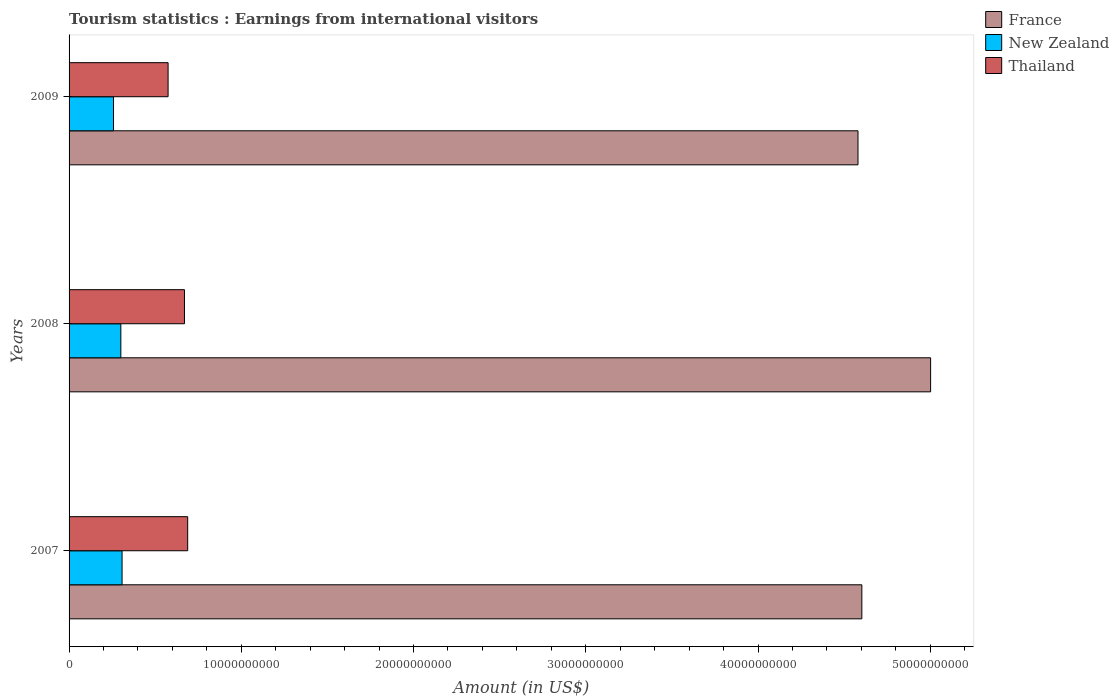How many different coloured bars are there?
Keep it short and to the point. 3. How many groups of bars are there?
Give a very brief answer. 3. Are the number of bars per tick equal to the number of legend labels?
Your response must be concise. Yes. In how many cases, is the number of bars for a given year not equal to the number of legend labels?
Provide a succinct answer. 0. What is the earnings from international visitors in Thailand in 2007?
Offer a terse response. 6.89e+09. Across all years, what is the maximum earnings from international visitors in New Zealand?
Offer a terse response. 3.08e+09. Across all years, what is the minimum earnings from international visitors in New Zealand?
Ensure brevity in your answer.  2.58e+09. In which year was the earnings from international visitors in France maximum?
Provide a succinct answer. 2008. In which year was the earnings from international visitors in France minimum?
Provide a short and direct response. 2009. What is the total earnings from international visitors in New Zealand in the graph?
Your answer should be very brief. 8.66e+09. What is the difference between the earnings from international visitors in Thailand in 2008 and that in 2009?
Make the answer very short. 9.51e+08. What is the difference between the earnings from international visitors in France in 2008 and the earnings from international visitors in Thailand in 2007?
Ensure brevity in your answer.  4.31e+1. What is the average earnings from international visitors in France per year?
Give a very brief answer. 4.73e+1. In the year 2009, what is the difference between the earnings from international visitors in Thailand and earnings from international visitors in France?
Provide a succinct answer. -4.01e+1. In how many years, is the earnings from international visitors in Thailand greater than 14000000000 US$?
Your answer should be very brief. 0. What is the ratio of the earnings from international visitors in France in 2008 to that in 2009?
Your answer should be compact. 1.09. Is the earnings from international visitors in France in 2008 less than that in 2009?
Your answer should be very brief. No. Is the difference between the earnings from international visitors in Thailand in 2007 and 2008 greater than the difference between the earnings from international visitors in France in 2007 and 2008?
Your answer should be very brief. Yes. What is the difference between the highest and the second highest earnings from international visitors in New Zealand?
Offer a very short reply. 7.10e+07. What is the difference between the highest and the lowest earnings from international visitors in New Zealand?
Your answer should be very brief. 4.97e+08. What does the 2nd bar from the top in 2008 represents?
Your response must be concise. New Zealand. What does the 2nd bar from the bottom in 2009 represents?
Your answer should be compact. New Zealand. Is it the case that in every year, the sum of the earnings from international visitors in Thailand and earnings from international visitors in New Zealand is greater than the earnings from international visitors in France?
Provide a succinct answer. No. How many bars are there?
Provide a short and direct response. 9. Are all the bars in the graph horizontal?
Offer a very short reply. Yes. How many years are there in the graph?
Your answer should be compact. 3. What is the difference between two consecutive major ticks on the X-axis?
Your response must be concise. 1.00e+1. Are the values on the major ticks of X-axis written in scientific E-notation?
Provide a short and direct response. No. How many legend labels are there?
Your answer should be very brief. 3. How are the legend labels stacked?
Keep it short and to the point. Vertical. What is the title of the graph?
Provide a short and direct response. Tourism statistics : Earnings from international visitors. What is the Amount (in US$) in France in 2007?
Your response must be concise. 4.60e+1. What is the Amount (in US$) in New Zealand in 2007?
Give a very brief answer. 3.08e+09. What is the Amount (in US$) in Thailand in 2007?
Keep it short and to the point. 6.89e+09. What is the Amount (in US$) in France in 2008?
Provide a short and direct response. 5.00e+1. What is the Amount (in US$) of New Zealand in 2008?
Offer a terse response. 3.01e+09. What is the Amount (in US$) of Thailand in 2008?
Your response must be concise. 6.70e+09. What is the Amount (in US$) in France in 2009?
Provide a succinct answer. 4.58e+1. What is the Amount (in US$) of New Zealand in 2009?
Provide a succinct answer. 2.58e+09. What is the Amount (in US$) in Thailand in 2009?
Ensure brevity in your answer.  5.75e+09. Across all years, what is the maximum Amount (in US$) in France?
Your answer should be very brief. 5.00e+1. Across all years, what is the maximum Amount (in US$) of New Zealand?
Offer a very short reply. 3.08e+09. Across all years, what is the maximum Amount (in US$) in Thailand?
Keep it short and to the point. 6.89e+09. Across all years, what is the minimum Amount (in US$) in France?
Make the answer very short. 4.58e+1. Across all years, what is the minimum Amount (in US$) in New Zealand?
Ensure brevity in your answer.  2.58e+09. Across all years, what is the minimum Amount (in US$) of Thailand?
Make the answer very short. 5.75e+09. What is the total Amount (in US$) in France in the graph?
Your answer should be compact. 1.42e+11. What is the total Amount (in US$) of New Zealand in the graph?
Your response must be concise. 8.66e+09. What is the total Amount (in US$) of Thailand in the graph?
Ensure brevity in your answer.  1.93e+1. What is the difference between the Amount (in US$) in France in 2007 and that in 2008?
Make the answer very short. -3.99e+09. What is the difference between the Amount (in US$) of New Zealand in 2007 and that in 2008?
Provide a short and direct response. 7.10e+07. What is the difference between the Amount (in US$) of Thailand in 2007 and that in 2008?
Keep it short and to the point. 1.87e+08. What is the difference between the Amount (in US$) of France in 2007 and that in 2009?
Your answer should be very brief. 2.23e+08. What is the difference between the Amount (in US$) in New Zealand in 2007 and that in 2009?
Ensure brevity in your answer.  4.97e+08. What is the difference between the Amount (in US$) of Thailand in 2007 and that in 2009?
Ensure brevity in your answer.  1.14e+09. What is the difference between the Amount (in US$) in France in 2008 and that in 2009?
Make the answer very short. 4.22e+09. What is the difference between the Amount (in US$) of New Zealand in 2008 and that in 2009?
Your answer should be compact. 4.26e+08. What is the difference between the Amount (in US$) of Thailand in 2008 and that in 2009?
Your answer should be compact. 9.51e+08. What is the difference between the Amount (in US$) in France in 2007 and the Amount (in US$) in New Zealand in 2008?
Provide a short and direct response. 4.30e+1. What is the difference between the Amount (in US$) in France in 2007 and the Amount (in US$) in Thailand in 2008?
Give a very brief answer. 3.93e+1. What is the difference between the Amount (in US$) in New Zealand in 2007 and the Amount (in US$) in Thailand in 2008?
Offer a terse response. -3.62e+09. What is the difference between the Amount (in US$) of France in 2007 and the Amount (in US$) of New Zealand in 2009?
Your answer should be very brief. 4.34e+1. What is the difference between the Amount (in US$) in France in 2007 and the Amount (in US$) in Thailand in 2009?
Offer a terse response. 4.03e+1. What is the difference between the Amount (in US$) of New Zealand in 2007 and the Amount (in US$) of Thailand in 2009?
Provide a short and direct response. -2.67e+09. What is the difference between the Amount (in US$) of France in 2008 and the Amount (in US$) of New Zealand in 2009?
Provide a short and direct response. 4.74e+1. What is the difference between the Amount (in US$) of France in 2008 and the Amount (in US$) of Thailand in 2009?
Your answer should be compact. 4.43e+1. What is the difference between the Amount (in US$) in New Zealand in 2008 and the Amount (in US$) in Thailand in 2009?
Ensure brevity in your answer.  -2.74e+09. What is the average Amount (in US$) in France per year?
Ensure brevity in your answer.  4.73e+1. What is the average Amount (in US$) in New Zealand per year?
Your answer should be very brief. 2.89e+09. What is the average Amount (in US$) in Thailand per year?
Ensure brevity in your answer.  6.45e+09. In the year 2007, what is the difference between the Amount (in US$) in France and Amount (in US$) in New Zealand?
Your answer should be compact. 4.30e+1. In the year 2007, what is the difference between the Amount (in US$) of France and Amount (in US$) of Thailand?
Offer a very short reply. 3.91e+1. In the year 2007, what is the difference between the Amount (in US$) of New Zealand and Amount (in US$) of Thailand?
Ensure brevity in your answer.  -3.81e+09. In the year 2008, what is the difference between the Amount (in US$) of France and Amount (in US$) of New Zealand?
Make the answer very short. 4.70e+1. In the year 2008, what is the difference between the Amount (in US$) in France and Amount (in US$) in Thailand?
Your answer should be compact. 4.33e+1. In the year 2008, what is the difference between the Amount (in US$) in New Zealand and Amount (in US$) in Thailand?
Provide a short and direct response. -3.69e+09. In the year 2009, what is the difference between the Amount (in US$) in France and Amount (in US$) in New Zealand?
Ensure brevity in your answer.  4.32e+1. In the year 2009, what is the difference between the Amount (in US$) of France and Amount (in US$) of Thailand?
Make the answer very short. 4.01e+1. In the year 2009, what is the difference between the Amount (in US$) in New Zealand and Amount (in US$) in Thailand?
Your answer should be compact. -3.17e+09. What is the ratio of the Amount (in US$) of France in 2007 to that in 2008?
Keep it short and to the point. 0.92. What is the ratio of the Amount (in US$) in New Zealand in 2007 to that in 2008?
Keep it short and to the point. 1.02. What is the ratio of the Amount (in US$) of Thailand in 2007 to that in 2008?
Your answer should be compact. 1.03. What is the ratio of the Amount (in US$) of France in 2007 to that in 2009?
Your answer should be compact. 1. What is the ratio of the Amount (in US$) in New Zealand in 2007 to that in 2009?
Make the answer very short. 1.19. What is the ratio of the Amount (in US$) in Thailand in 2007 to that in 2009?
Offer a terse response. 1.2. What is the ratio of the Amount (in US$) in France in 2008 to that in 2009?
Your response must be concise. 1.09. What is the ratio of the Amount (in US$) in New Zealand in 2008 to that in 2009?
Keep it short and to the point. 1.17. What is the ratio of the Amount (in US$) in Thailand in 2008 to that in 2009?
Provide a succinct answer. 1.17. What is the difference between the highest and the second highest Amount (in US$) in France?
Your answer should be compact. 3.99e+09. What is the difference between the highest and the second highest Amount (in US$) in New Zealand?
Ensure brevity in your answer.  7.10e+07. What is the difference between the highest and the second highest Amount (in US$) of Thailand?
Give a very brief answer. 1.87e+08. What is the difference between the highest and the lowest Amount (in US$) of France?
Keep it short and to the point. 4.22e+09. What is the difference between the highest and the lowest Amount (in US$) in New Zealand?
Provide a short and direct response. 4.97e+08. What is the difference between the highest and the lowest Amount (in US$) of Thailand?
Your response must be concise. 1.14e+09. 